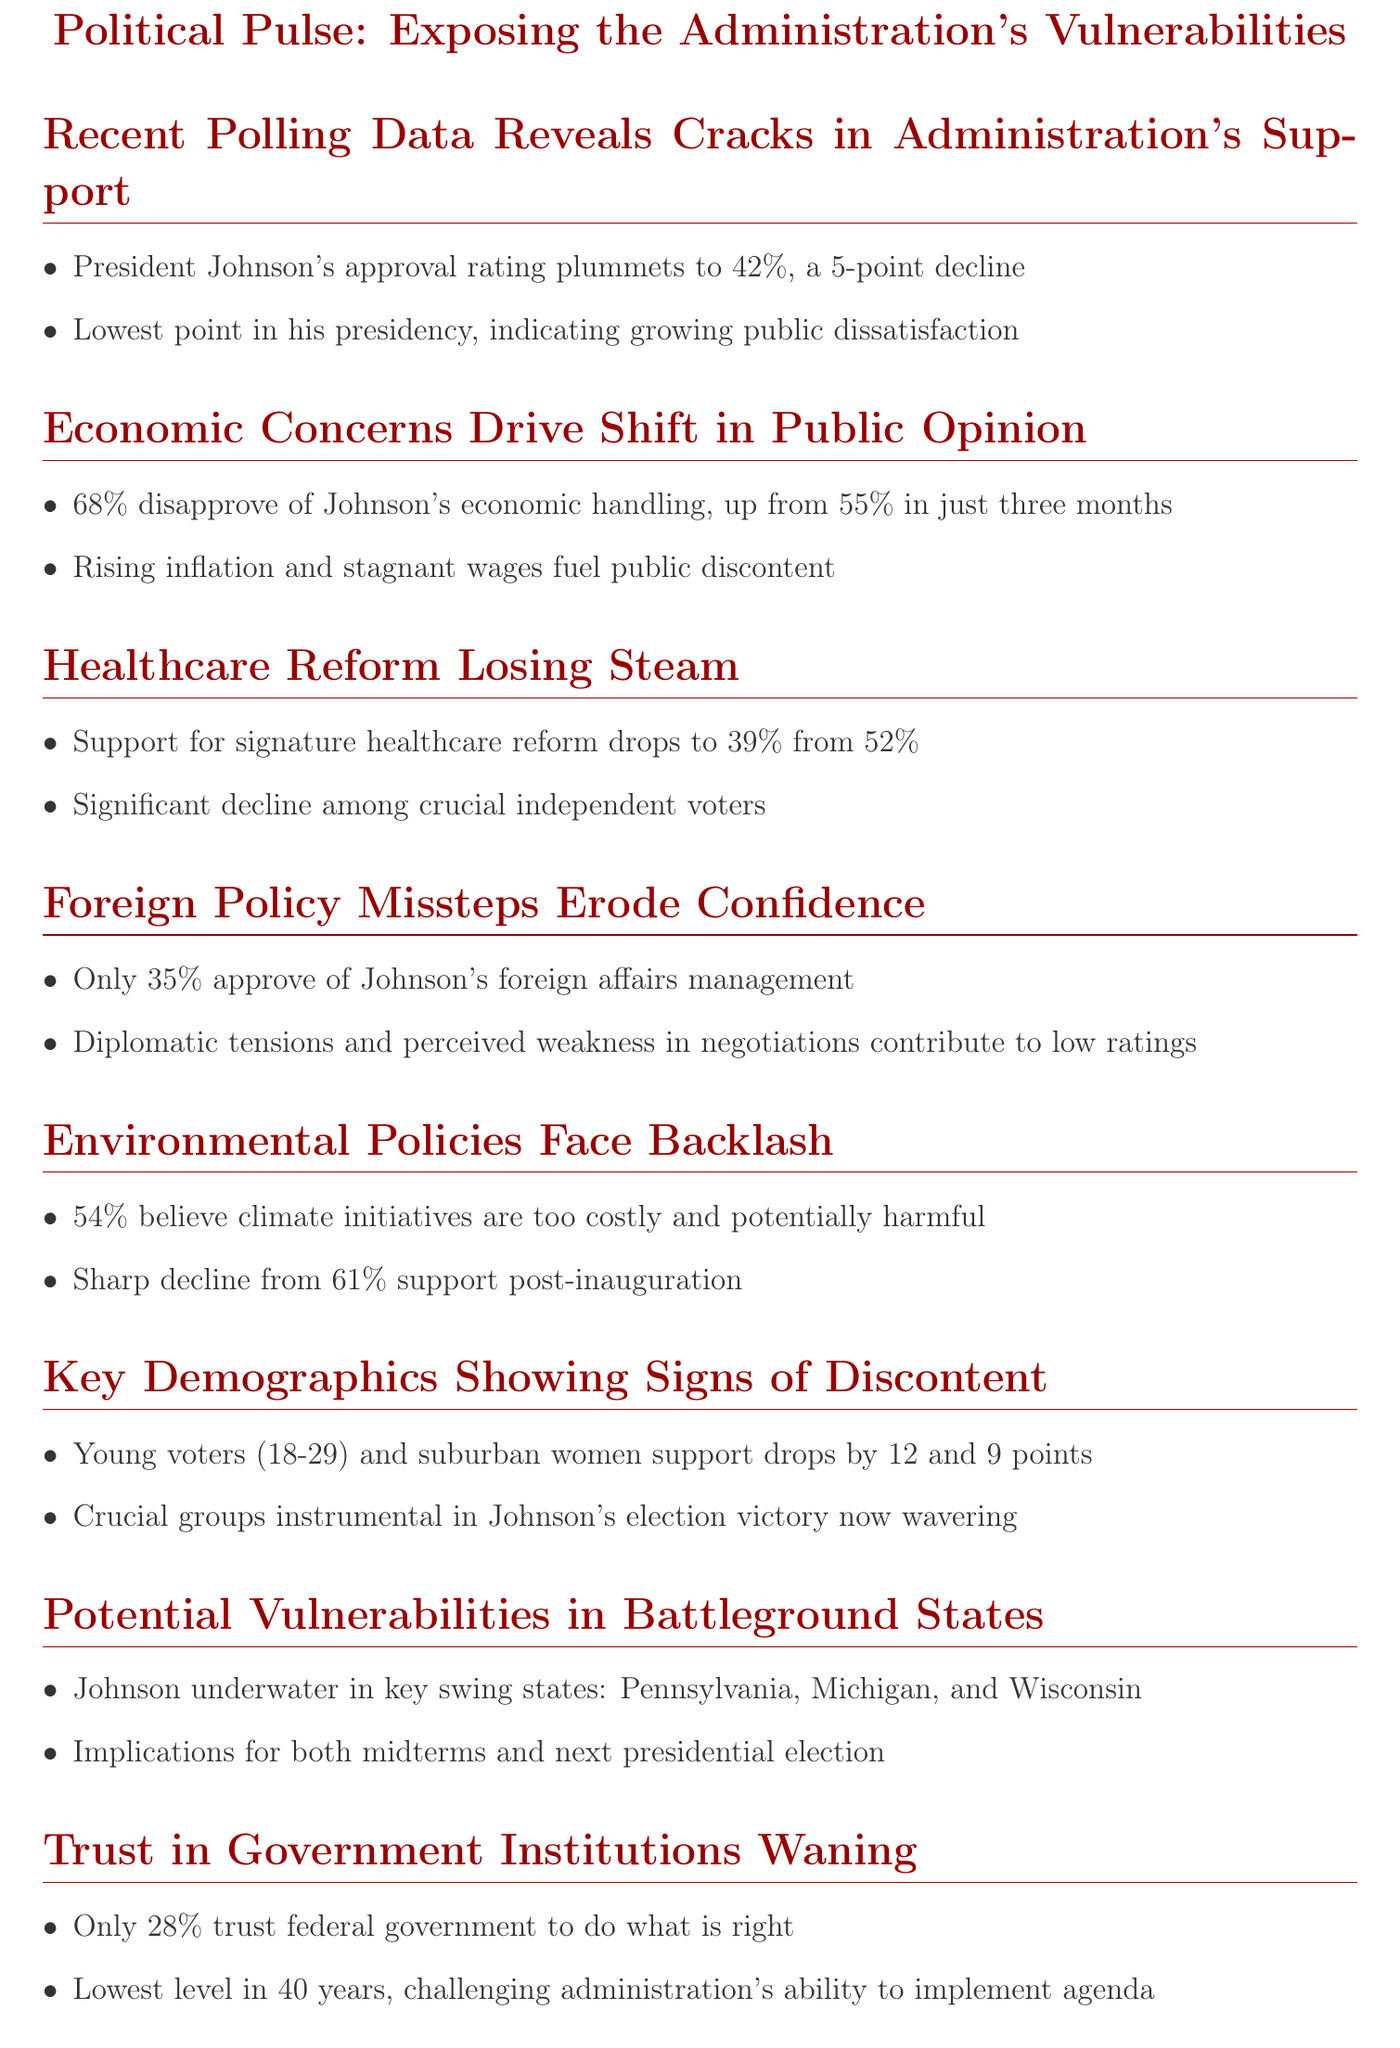What is President Johnson's approval rating? The document states that President Johnson's approval rating has dropped to 42%.
Answer: 42% What percentage of Americans disapprove of Johnson's handling of the economy? According to the Pew Research Center survey, 68% of Americans disapprove of President Johnson's handling of the economy.
Answer: 68% What was the support for the healthcare reform at the beginning of the year? The Kaiser Family Foundation's latest poll indicates that support for the administration's signature healthcare reform was 52% at the beginning of the year.
Answer: 52% How much has support among young voters decreased since the last election? A Quinnipiac University poll highlights that support among young voters has fallen by 12 points.
Answer: 12 points What is the current public trust percentage in federal government? An ABC News/Washington Post poll indicates that only 28% of Americans trust the federal government to do what is right.
Answer: 28% Which demographic showed a 9-point decrease in support? The document mentions suburban women showed a 9-point decrease in support since last election.
Answer: Suburban women In which states is President Johnson's approval rating underwater? The latest Morning Consult state-by-state approval ratings show President Johnson underwater in key swing states like Pennsylvania, Michigan, and Wisconsin.
Answer: Pennsylvania, Michigan, Wisconsin What is the percentage of Americans who believe climate initiatives are too costly? The latest YouGov/Economist poll shows that 54% of Americans believe the administration's climate initiatives are too costly.
Answer: 54% What was the support for climate initiatives just after Johnson took office? The document indicates that support for climate initiatives was 61% just after President Johnson took office.
Answer: 61% 